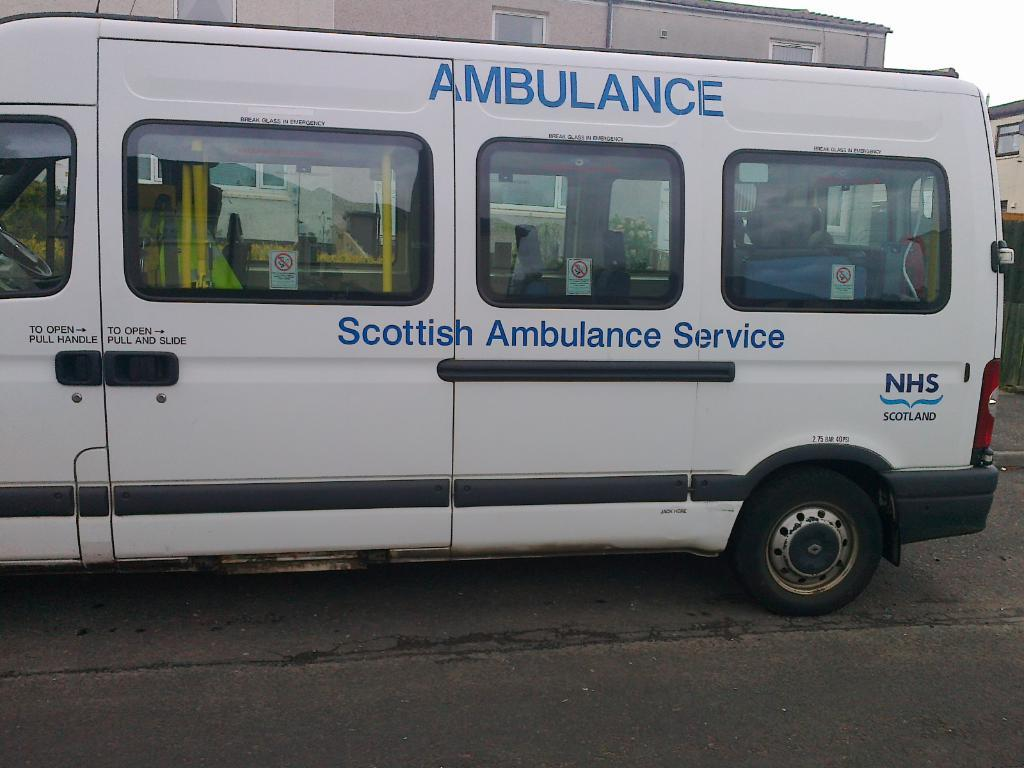<image>
Summarize the visual content of the image. A white van that says Scottish Ambulance Service down the side of it. 